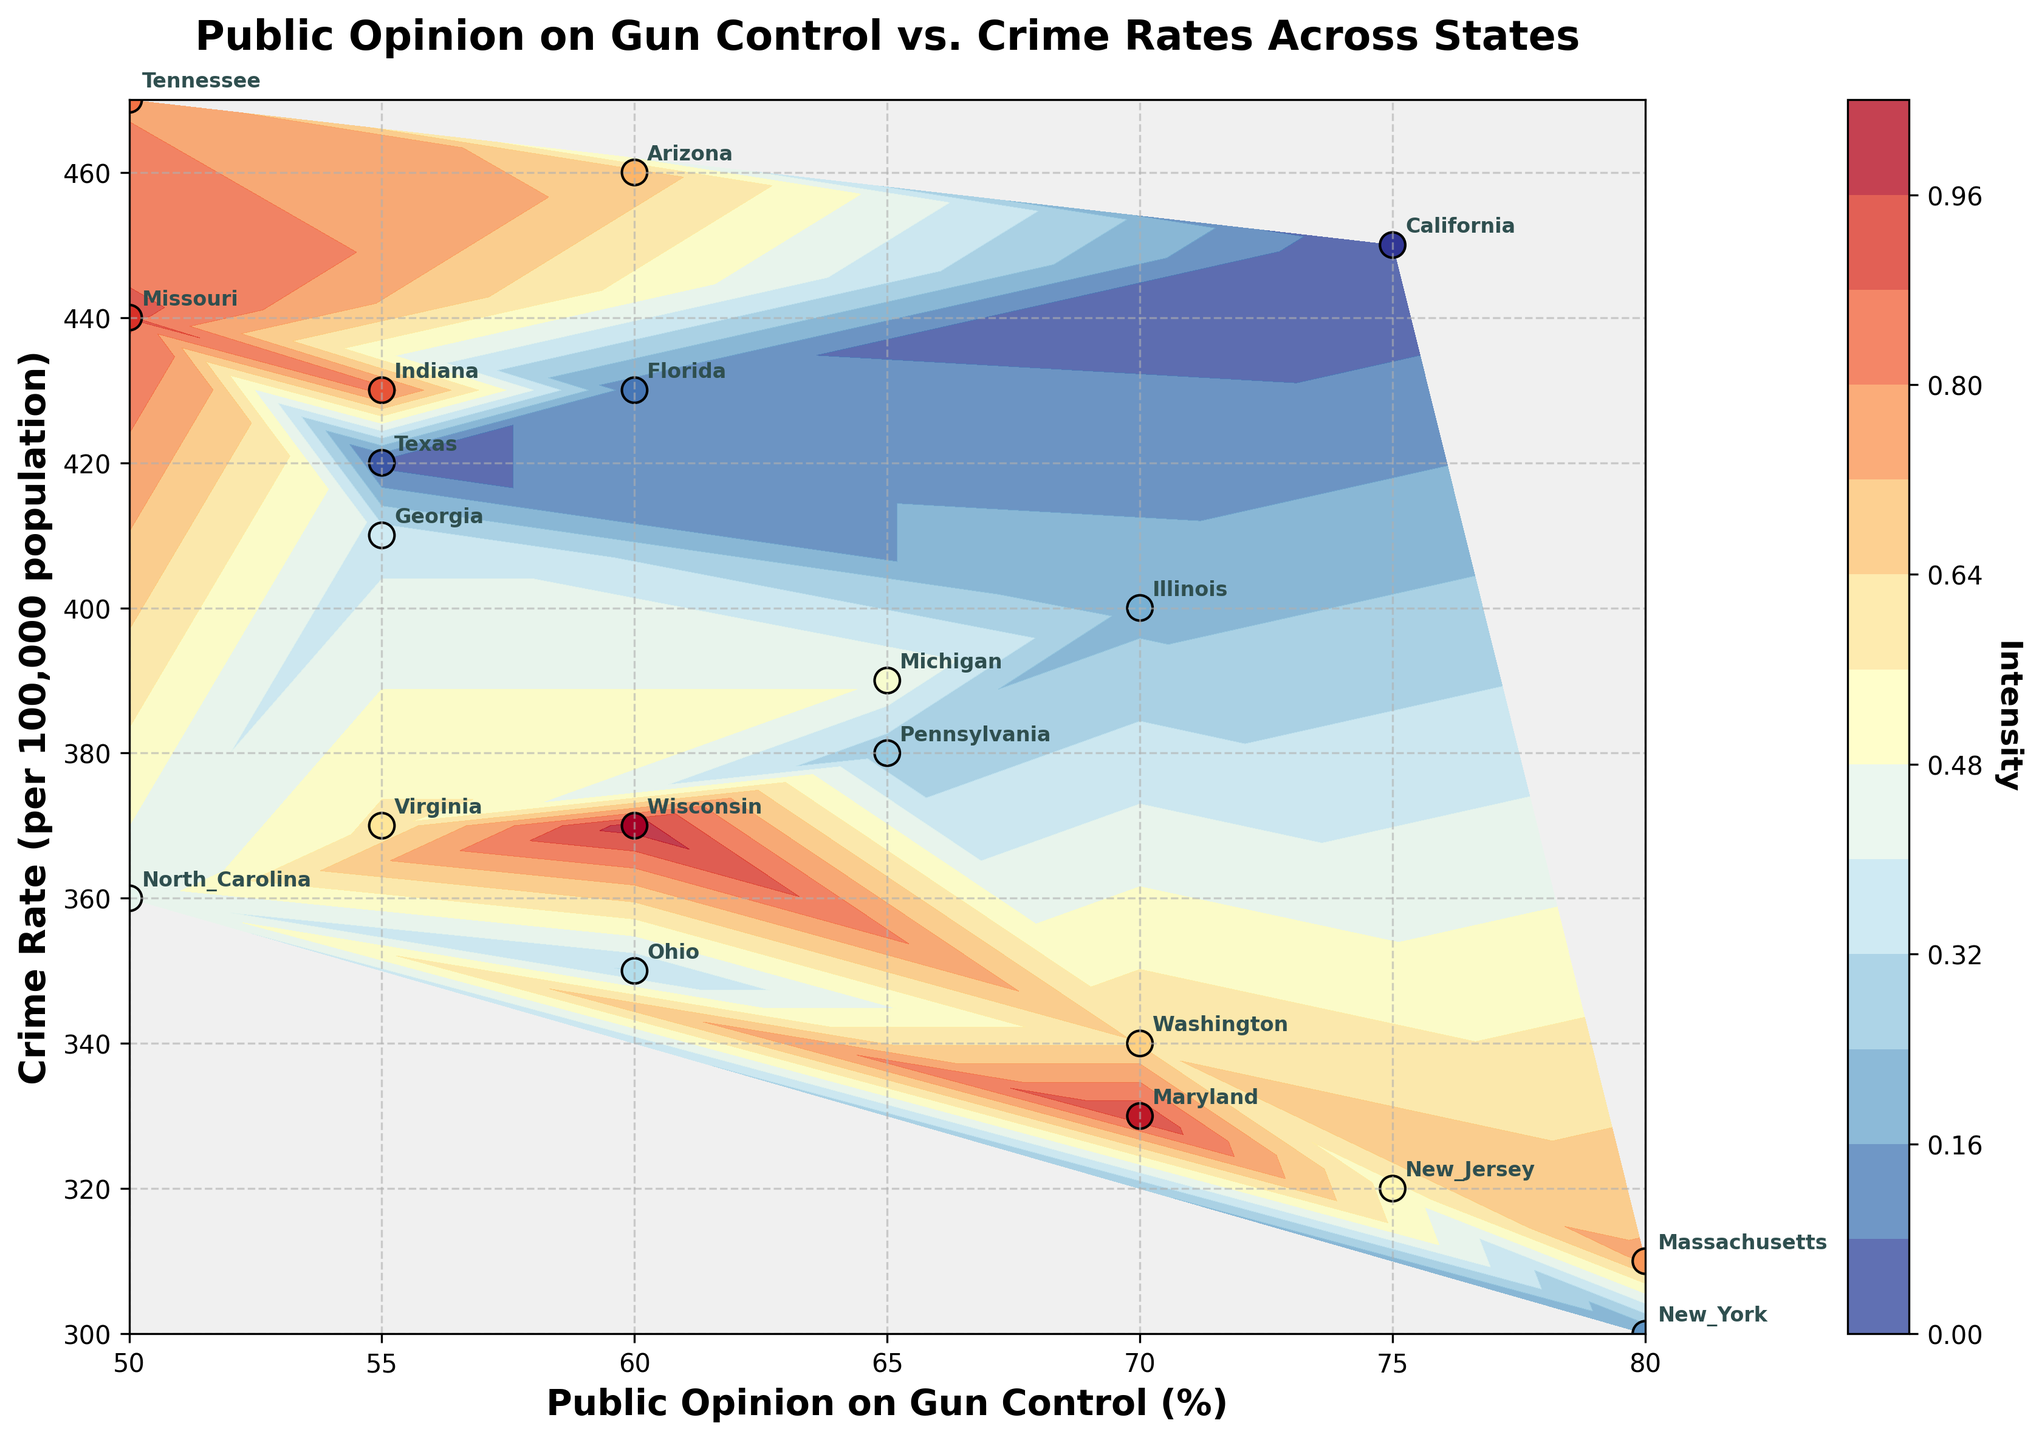How many data points are shown in the plot? The plot displays 19 data points, one for each state listed in the dataset. By counting the number of annotated states or the scatter points, we confirm this number.
Answer: 19 What is the title of the plot? The title of the plot is displayed at the top of the figure in bold font. It reads: "Public Opinion on Gun Control vs. Crime Rates Across States".
Answer: "Public Opinion on Gun Control vs. Crime Rates Across States" Which state has the highest crime rate? The y-axis represents the crime rate, and from scanning the data points, Tennessee has the highest crime rate at 470 per 100,000 population.
Answer: Tennessee Which state shows the highest public opinion on gun control? The x-axis represents public opinion on gun control, and by examining the data points, both New York and Massachusetts have the highest value at 80%.
Answer: New York and Massachusetts What is the intensity color range used in the contour plot? The contour plot uses shades from the 'RdYlBu_r' colormap, ranging from blue to red. This can be observed in the color gradient shown in the color bar legend on the right side of the plot.
Answer: Blue to Red Which states have a crime rate lower than 350 and what are their public opinion values? Referring to the y-axis, states with a crime rate lower than 350 are New York (300), New Jersey (320), Maryland (330), and Washington (340). Their public opinion values on gun control are New York (80), New Jersey (75), Maryland (70), and Washington (70).
Answer: New York (80), New Jersey (75), Maryland (70), Washington (70) What’s the difference in crime rates between California and Texas? California has a crime rate of 450, while Texas has a crime rate of 420. The difference is obtained by subtracting 420 from 450, giving 30.
Answer: 30 Compare the public opinion on gun control for Pennsylvania and Georgia. Which state has a higher percentage, and by how much? The public opinion percentages for Pennsylvania and Georgia are 65% and 55%, respectively. Pennsylvania has a higher percentage. The difference is 65 - 55 = 10%.
Answer: Pennsylvania by 10% Which state has the lowest public opinion on gun control, and what is its corresponding crime rate? Referring to the x-axis, North Carolina has the lowest public opinion on gun control at 50%. The corresponding crime rate for North Carolina is 360 per 100,000 population.
Answer: North Carolina, 360 